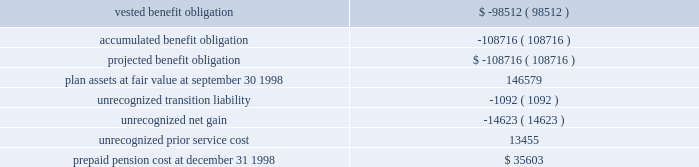The containerboard group ( a division of tenneco packaging inc. ) notes to combined financial statements ( continued ) april 11 , 1999 5 .
Pension and other benefit plans ( continued ) the funded status of the group 2019s allocation of defined benefit plans , excluding the retirement plan , reconciles with amounts recognized in the 1998 statements of assets and liabilities and interdivision account as follows ( in thousands ) : actuarial present value at september 30 , 1998 2014 .
The weighted average discount rate used in determining the actuarial present value of the benefit obligations was 7.00% ( 7.00 % ) for the year ended december 31 , 1998 .
The weighted average expected long-term rate of return on plan assets was 10% ( 10 % ) for 1998 .
Middle management employees participate in a variety of incentive compensation plans .
These plans provide for incentive payments based on the achievement of certain targeted operating results and other specific business goals .
The targeted operating results are determined each year by senior management of packaging .
The amounts charged to expense for these plans were $ 1599000 for the period ended april 11 , 1999 .
In june , 1992 , tenneco initiated an employee stock purchase plan ( 2018 2018espp 2019 2019 ) .
The plan allows u.s .
And canadian employees of the group to purchase tenneco inc .
Common stock through payroll deductions at a 15% ( 15 % ) discount .
Each year , an employee in the plan may purchase shares with a discounted value not to exceed $ 21250 .
The weighted average fair value of the employee purchase right , which was estimated using the black-scholes option pricing model and the assumptions described below except that the average life of each purchase right was assumed to be 90 days , was $ 6.31 for the period ended december 31 , 1998 .
The espp was terminated as of september 30 , 1996 .
Tenneco adopted a new employee stock purchase plan effective april 1 , 1997 .
Under the respective espps , tenneco sold 36883 shares to group employees for the period ended april 11 , 1999 .
In december , 1996 , tenneco adopted the 1996 stock ownership plan , which permits the granting of a variety of awards , including common stock , restricted stock , performance units , stock appreciation rights , and stock options to officers and employees of tenneco .
Tenneco can issue up to 17000000 shares of common stock under this plan , which will terminate december 31 , 2001 .
The april 11 , 1999 , fair market value of the options granted was calculated using tenneco 2019s stock price at the grant date and multiplying the amount by the historical percentage of past black-scholes pricing values fair value ( approximately 25% ( 25 % ) ) .
The fair value of each stock option issued by tenneco to the group in prior periods was estimated on the date of grant using the black-sholes option pricing model using the following ranges of weighted average assumptions for grants during the past three .
Is the projected benefit obligation greater than the plan assets at fair value at september 30 1998? 
Computations: (-108716 > 146579)
Answer: no. The containerboard group ( a division of tenneco packaging inc. ) notes to combined financial statements ( continued ) april 11 , 1999 5 .
Pension and other benefit plans ( continued ) the funded status of the group 2019s allocation of defined benefit plans , excluding the retirement plan , reconciles with amounts recognized in the 1998 statements of assets and liabilities and interdivision account as follows ( in thousands ) : actuarial present value at september 30 , 1998 2014 .
The weighted average discount rate used in determining the actuarial present value of the benefit obligations was 7.00% ( 7.00 % ) for the year ended december 31 , 1998 .
The weighted average expected long-term rate of return on plan assets was 10% ( 10 % ) for 1998 .
Middle management employees participate in a variety of incentive compensation plans .
These plans provide for incentive payments based on the achievement of certain targeted operating results and other specific business goals .
The targeted operating results are determined each year by senior management of packaging .
The amounts charged to expense for these plans were $ 1599000 for the period ended april 11 , 1999 .
In june , 1992 , tenneco initiated an employee stock purchase plan ( 2018 2018espp 2019 2019 ) .
The plan allows u.s .
And canadian employees of the group to purchase tenneco inc .
Common stock through payroll deductions at a 15% ( 15 % ) discount .
Each year , an employee in the plan may purchase shares with a discounted value not to exceed $ 21250 .
The weighted average fair value of the employee purchase right , which was estimated using the black-scholes option pricing model and the assumptions described below except that the average life of each purchase right was assumed to be 90 days , was $ 6.31 for the period ended december 31 , 1998 .
The espp was terminated as of september 30 , 1996 .
Tenneco adopted a new employee stock purchase plan effective april 1 , 1997 .
Under the respective espps , tenneco sold 36883 shares to group employees for the period ended april 11 , 1999 .
In december , 1996 , tenneco adopted the 1996 stock ownership plan , which permits the granting of a variety of awards , including common stock , restricted stock , performance units , stock appreciation rights , and stock options to officers and employees of tenneco .
Tenneco can issue up to 17000000 shares of common stock under this plan , which will terminate december 31 , 2001 .
The april 11 , 1999 , fair market value of the options granted was calculated using tenneco 2019s stock price at the grant date and multiplying the amount by the historical percentage of past black-scholes pricing values fair value ( approximately 25% ( 25 % ) ) .
The fair value of each stock option issued by tenneco to the group in prior periods was estimated on the date of grant using the black-sholes option pricing model using the following ranges of weighted average assumptions for grants during the past three .
What is the difference between the weighted average expected long-term rate of return on plan assets for 1998 and the weighted average discount rate used in determining the actuarial present value of the benefit obligations in 1998? 
Rationale: any negative in this equation lays a liability on the company . so long term returns have to be monitored .
Computations: (10% - 7.00%)
Answer: 0.03. 